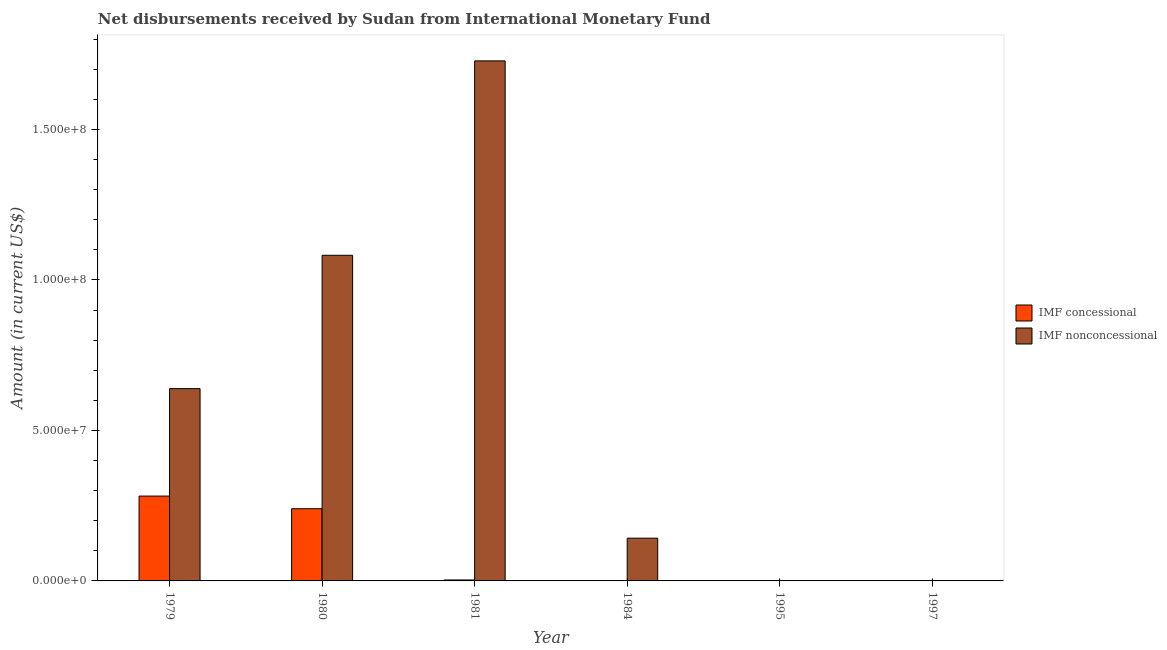Are the number of bars on each tick of the X-axis equal?
Ensure brevity in your answer.  No. How many bars are there on the 4th tick from the left?
Offer a terse response. 1. How many bars are there on the 1st tick from the right?
Make the answer very short. 0. In how many cases, is the number of bars for a given year not equal to the number of legend labels?
Your answer should be very brief. 3. Across all years, what is the maximum net concessional disbursements from imf?
Make the answer very short. 2.82e+07. What is the total net concessional disbursements from imf in the graph?
Keep it short and to the point. 5.25e+07. What is the difference between the net non concessional disbursements from imf in 1981 and that in 1984?
Give a very brief answer. 1.59e+08. What is the difference between the net concessional disbursements from imf in 1997 and the net non concessional disbursements from imf in 1979?
Give a very brief answer. -2.82e+07. What is the average net non concessional disbursements from imf per year?
Offer a very short reply. 5.98e+07. In the year 1979, what is the difference between the net non concessional disbursements from imf and net concessional disbursements from imf?
Provide a short and direct response. 0. In how many years, is the net non concessional disbursements from imf greater than 10000000 US$?
Give a very brief answer. 4. What is the ratio of the net non concessional disbursements from imf in 1981 to that in 1984?
Give a very brief answer. 12.17. Is the net concessional disbursements from imf in 1979 less than that in 1980?
Offer a terse response. No. What is the difference between the highest and the second highest net concessional disbursements from imf?
Offer a very short reply. 4.20e+06. What is the difference between the highest and the lowest net concessional disbursements from imf?
Provide a succinct answer. 2.82e+07. In how many years, is the net non concessional disbursements from imf greater than the average net non concessional disbursements from imf taken over all years?
Offer a terse response. 3. How many years are there in the graph?
Offer a terse response. 6. Are the values on the major ticks of Y-axis written in scientific E-notation?
Your answer should be very brief. Yes. Does the graph contain any zero values?
Provide a succinct answer. Yes. Does the graph contain grids?
Offer a very short reply. No. Where does the legend appear in the graph?
Offer a very short reply. Center right. How many legend labels are there?
Offer a terse response. 2. What is the title of the graph?
Make the answer very short. Net disbursements received by Sudan from International Monetary Fund. What is the label or title of the Y-axis?
Your response must be concise. Amount (in current US$). What is the Amount (in current US$) in IMF concessional in 1979?
Offer a very short reply. 2.82e+07. What is the Amount (in current US$) in IMF nonconcessional in 1979?
Your answer should be compact. 6.39e+07. What is the Amount (in current US$) of IMF concessional in 1980?
Your answer should be compact. 2.40e+07. What is the Amount (in current US$) in IMF nonconcessional in 1980?
Give a very brief answer. 1.08e+08. What is the Amount (in current US$) in IMF nonconcessional in 1981?
Your response must be concise. 1.73e+08. What is the Amount (in current US$) of IMF concessional in 1984?
Ensure brevity in your answer.  0. What is the Amount (in current US$) in IMF nonconcessional in 1984?
Make the answer very short. 1.42e+07. What is the Amount (in current US$) in IMF concessional in 1997?
Give a very brief answer. 0. Across all years, what is the maximum Amount (in current US$) of IMF concessional?
Give a very brief answer. 2.82e+07. Across all years, what is the maximum Amount (in current US$) of IMF nonconcessional?
Keep it short and to the point. 1.73e+08. What is the total Amount (in current US$) of IMF concessional in the graph?
Your answer should be very brief. 5.25e+07. What is the total Amount (in current US$) of IMF nonconcessional in the graph?
Your answer should be very brief. 3.59e+08. What is the difference between the Amount (in current US$) of IMF concessional in 1979 and that in 1980?
Your answer should be compact. 4.20e+06. What is the difference between the Amount (in current US$) of IMF nonconcessional in 1979 and that in 1980?
Your response must be concise. -4.43e+07. What is the difference between the Amount (in current US$) of IMF concessional in 1979 and that in 1981?
Make the answer very short. 2.79e+07. What is the difference between the Amount (in current US$) in IMF nonconcessional in 1979 and that in 1981?
Provide a succinct answer. -1.09e+08. What is the difference between the Amount (in current US$) of IMF nonconcessional in 1979 and that in 1984?
Give a very brief answer. 4.97e+07. What is the difference between the Amount (in current US$) of IMF concessional in 1980 and that in 1981?
Provide a succinct answer. 2.37e+07. What is the difference between the Amount (in current US$) of IMF nonconcessional in 1980 and that in 1981?
Give a very brief answer. -6.46e+07. What is the difference between the Amount (in current US$) in IMF nonconcessional in 1980 and that in 1984?
Your response must be concise. 9.40e+07. What is the difference between the Amount (in current US$) of IMF nonconcessional in 1981 and that in 1984?
Offer a very short reply. 1.59e+08. What is the difference between the Amount (in current US$) in IMF concessional in 1979 and the Amount (in current US$) in IMF nonconcessional in 1980?
Ensure brevity in your answer.  -8.00e+07. What is the difference between the Amount (in current US$) in IMF concessional in 1979 and the Amount (in current US$) in IMF nonconcessional in 1981?
Your answer should be compact. -1.45e+08. What is the difference between the Amount (in current US$) of IMF concessional in 1979 and the Amount (in current US$) of IMF nonconcessional in 1984?
Provide a short and direct response. 1.40e+07. What is the difference between the Amount (in current US$) in IMF concessional in 1980 and the Amount (in current US$) in IMF nonconcessional in 1981?
Give a very brief answer. -1.49e+08. What is the difference between the Amount (in current US$) of IMF concessional in 1980 and the Amount (in current US$) of IMF nonconcessional in 1984?
Provide a succinct answer. 9.79e+06. What is the difference between the Amount (in current US$) of IMF concessional in 1981 and the Amount (in current US$) of IMF nonconcessional in 1984?
Your answer should be very brief. -1.39e+07. What is the average Amount (in current US$) in IMF concessional per year?
Give a very brief answer. 8.75e+06. What is the average Amount (in current US$) of IMF nonconcessional per year?
Your response must be concise. 5.98e+07. In the year 1979, what is the difference between the Amount (in current US$) of IMF concessional and Amount (in current US$) of IMF nonconcessional?
Offer a terse response. -3.57e+07. In the year 1980, what is the difference between the Amount (in current US$) of IMF concessional and Amount (in current US$) of IMF nonconcessional?
Offer a very short reply. -8.42e+07. In the year 1981, what is the difference between the Amount (in current US$) in IMF concessional and Amount (in current US$) in IMF nonconcessional?
Offer a very short reply. -1.72e+08. What is the ratio of the Amount (in current US$) of IMF concessional in 1979 to that in 1980?
Provide a succinct answer. 1.17. What is the ratio of the Amount (in current US$) of IMF nonconcessional in 1979 to that in 1980?
Ensure brevity in your answer.  0.59. What is the ratio of the Amount (in current US$) in IMF concessional in 1979 to that in 1981?
Offer a terse response. 88.08. What is the ratio of the Amount (in current US$) of IMF nonconcessional in 1979 to that in 1981?
Ensure brevity in your answer.  0.37. What is the ratio of the Amount (in current US$) of IMF nonconcessional in 1979 to that in 1984?
Your response must be concise. 4.5. What is the ratio of the Amount (in current US$) of IMF concessional in 1980 to that in 1981?
Keep it short and to the point. 74.97. What is the ratio of the Amount (in current US$) of IMF nonconcessional in 1980 to that in 1981?
Provide a succinct answer. 0.63. What is the ratio of the Amount (in current US$) of IMF nonconcessional in 1980 to that in 1984?
Give a very brief answer. 7.62. What is the ratio of the Amount (in current US$) in IMF nonconcessional in 1981 to that in 1984?
Ensure brevity in your answer.  12.17. What is the difference between the highest and the second highest Amount (in current US$) in IMF concessional?
Your response must be concise. 4.20e+06. What is the difference between the highest and the second highest Amount (in current US$) of IMF nonconcessional?
Make the answer very short. 6.46e+07. What is the difference between the highest and the lowest Amount (in current US$) in IMF concessional?
Give a very brief answer. 2.82e+07. What is the difference between the highest and the lowest Amount (in current US$) of IMF nonconcessional?
Keep it short and to the point. 1.73e+08. 